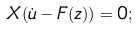<formula> <loc_0><loc_0><loc_500><loc_500>X ( \dot { u } - { F } ( z ) ) = 0 ;</formula> 